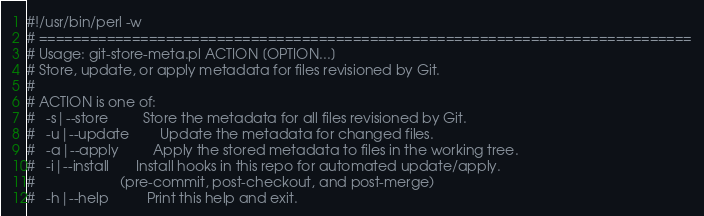Convert code to text. <code><loc_0><loc_0><loc_500><loc_500><_Perl_>#!/usr/bin/perl -w
# =============================================================================
# Usage: git-store-meta.pl ACTION [OPTION...]
# Store, update, or apply metadata for files revisioned by Git.
#
# ACTION is one of:
#   -s|--store         Store the metadata for all files revisioned by Git.
#   -u|--update        Update the metadata for changed files.
#   -a|--apply         Apply the stored metadata to files in the working tree.
#   -i|--install       Install hooks in this repo for automated update/apply.
#                      (pre-commit, post-checkout, and post-merge)
#   -h|--help          Print this help and exit.</code> 